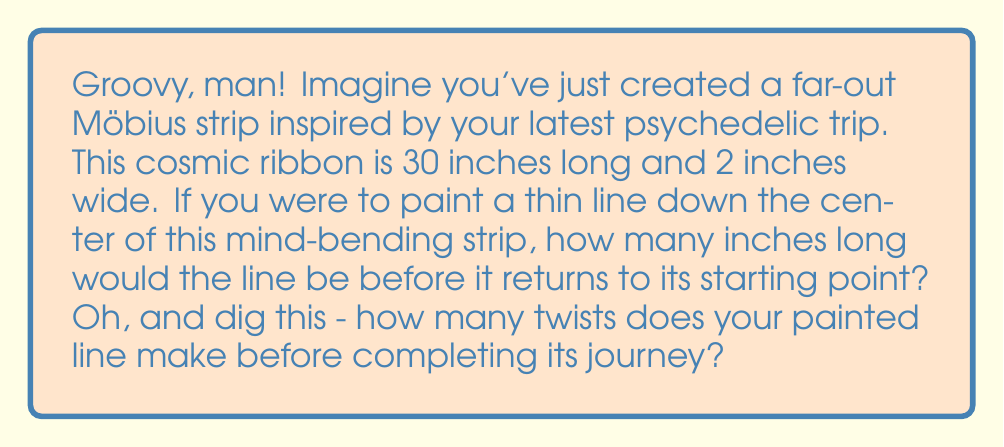Teach me how to tackle this problem. Alright, let's take a cosmic journey through this trippy topology problem, cats and kittens!

1) First, we need to understand the nature of a Möbius strip. It's a surface with only one side and one edge, man. Far out!

2) When you paint a line down the center of a Möbius strip, it travels along the entire length of the strip twice before returning to its starting point. This is because the strip has only one side, so the line needs to cover both "sides" of the original rectangle used to create the strip.

3) Given:
   - Length of the strip = 30 inches
   - Width of the strip = 2 inches (not directly relevant to this problem, but groovy to know)

4) The length of the painted line:
   $$\text{Line length} = 2 \times \text{Strip length} = 2 \times 30 = 60 \text{ inches}$$

5) Now, for the number of twists, we need to consider the topology of the Möbius strip. A standard Möbius strip has one half-twist. This means that after traveling once around the strip (30 inches), the line will be on the "opposite side" of where it started.

6) To return to the starting point, the line needs to go around once more, completing a full twist.

So, the painted line makes one full twist (or two half-twists) before returning to its starting point.

Far out, right? It's like the universe folding in on itself, man!
Answer: The painted line would be 60 inches long and make 1 full twist before returning to its starting point. 